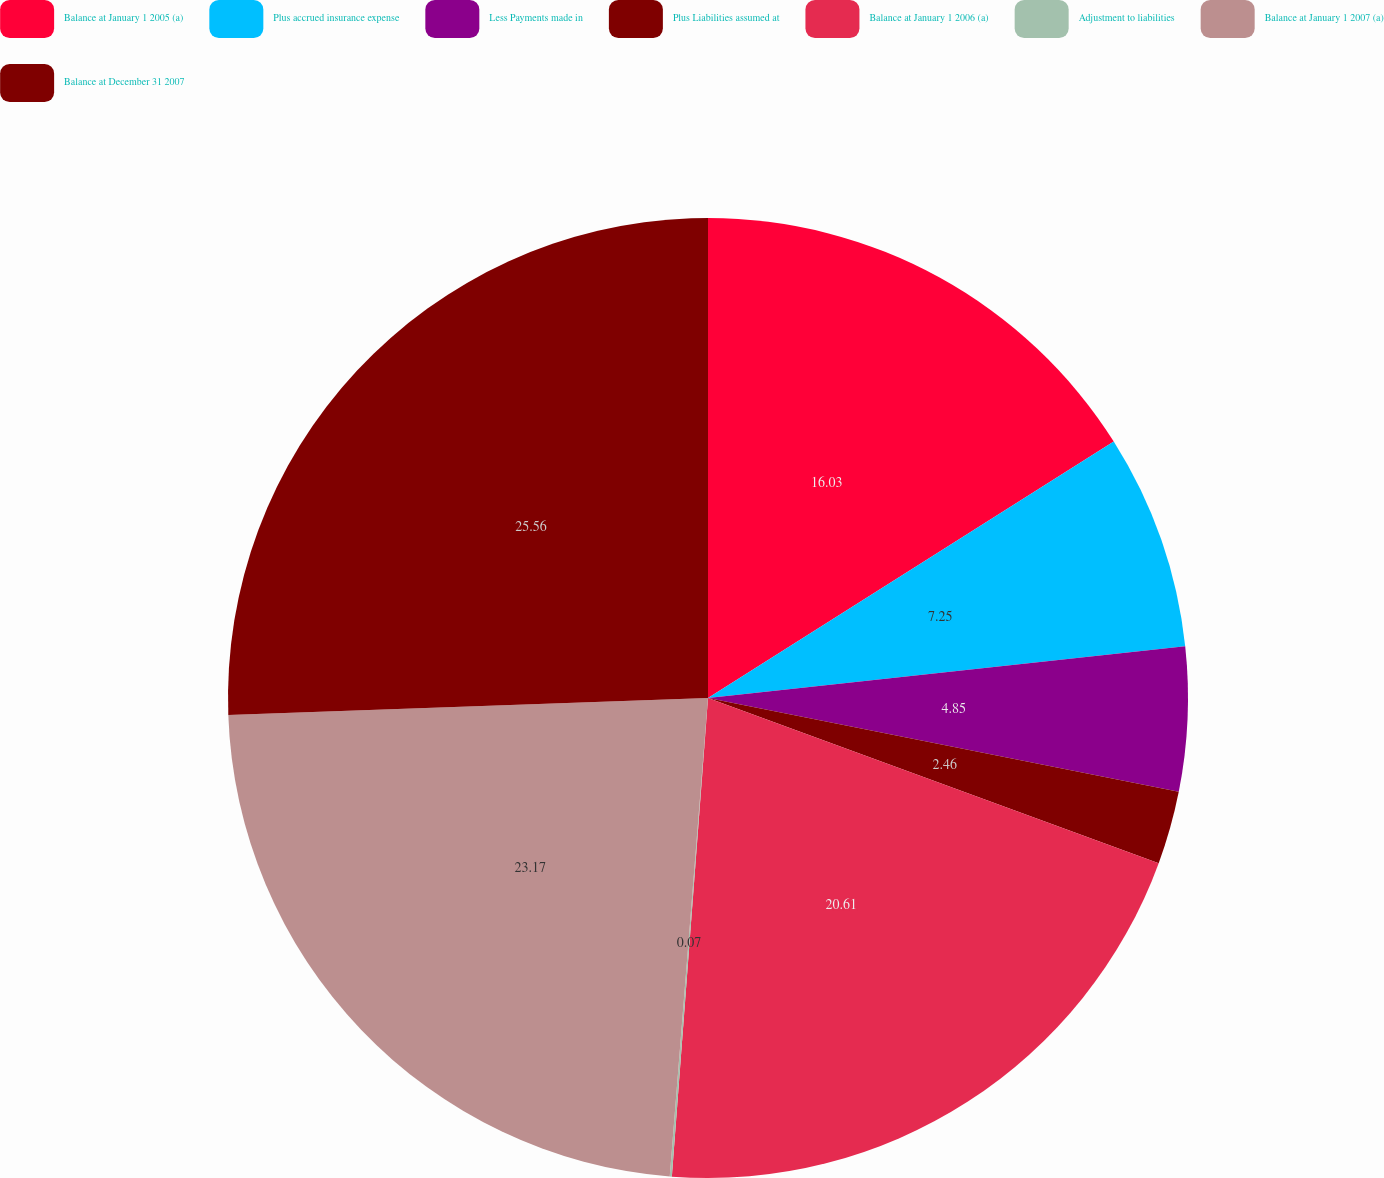Convert chart to OTSL. <chart><loc_0><loc_0><loc_500><loc_500><pie_chart><fcel>Balance at January 1 2005 (a)<fcel>Plus accrued insurance expense<fcel>Less Payments made in<fcel>Plus Liabilities assumed at<fcel>Balance at January 1 2006 (a)<fcel>Adjustment to liabilities<fcel>Balance at January 1 2007 (a)<fcel>Balance at December 31 2007<nl><fcel>16.03%<fcel>7.25%<fcel>4.85%<fcel>2.46%<fcel>20.61%<fcel>0.07%<fcel>23.17%<fcel>25.56%<nl></chart> 